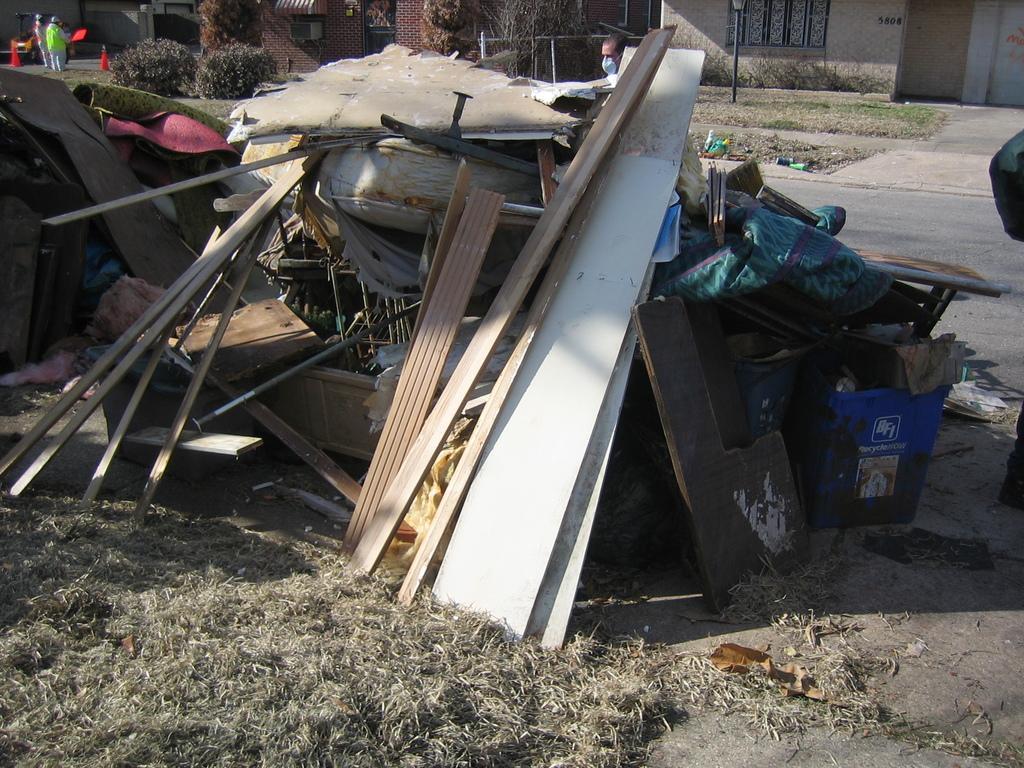How would you summarize this image in a sentence or two? In the center of the image we can see the scrap. In the background of the image we can see the dry grass, mesh, plants, buildings, windows. On the right side of the image we can see the road. In the top left corner we can see the divider cones and two people are standing. 